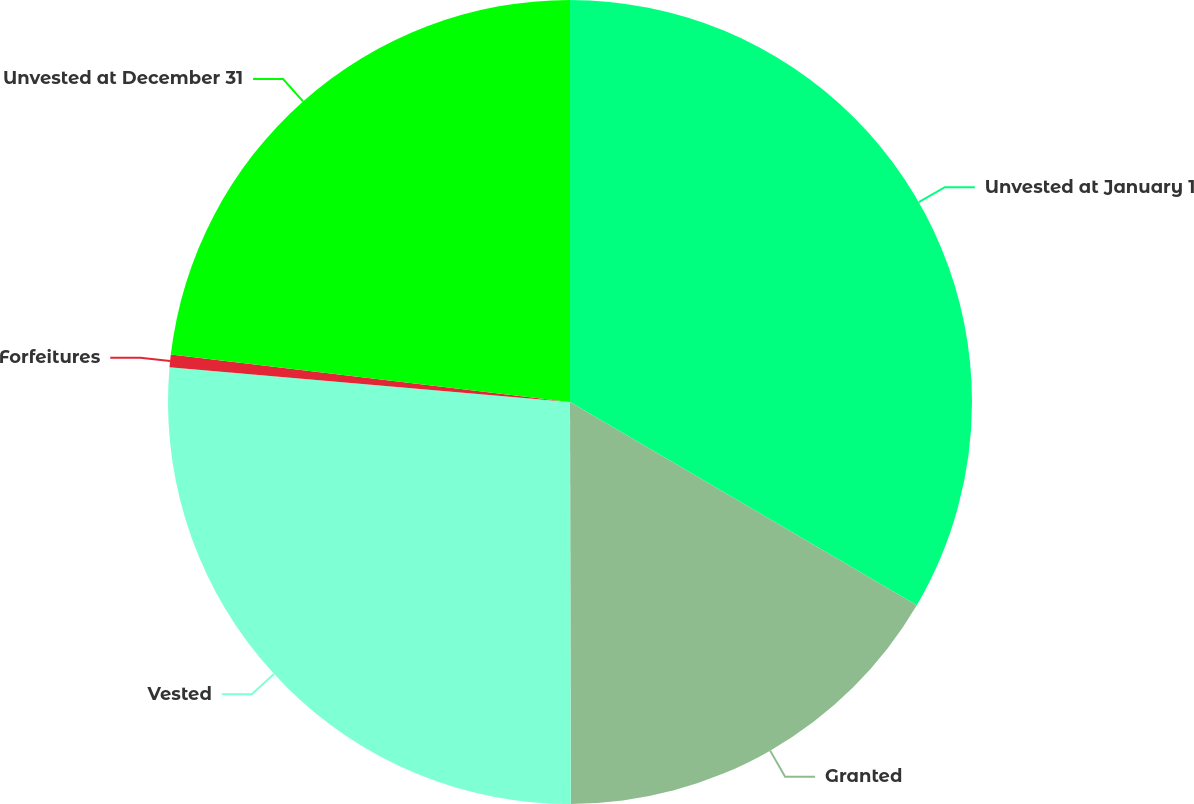<chart> <loc_0><loc_0><loc_500><loc_500><pie_chart><fcel>Unvested at January 1<fcel>Granted<fcel>Vested<fcel>Forfeitures<fcel>Unvested at December 31<nl><fcel>33.44%<fcel>16.53%<fcel>26.41%<fcel>0.5%<fcel>23.12%<nl></chart> 